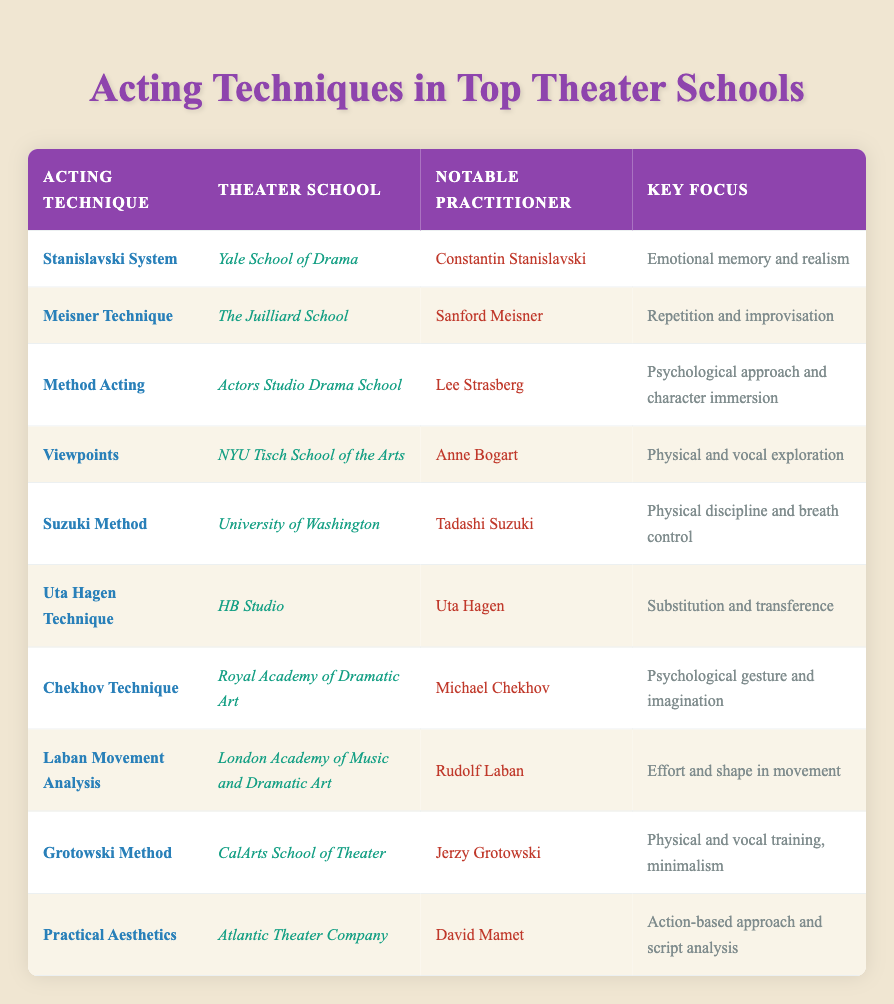What is the key focus of the Method Acting technique? The Method Acting technique is associated with the Actors Studio Drama School and emphasizes a psychological approach and character immersion. This information can be pulled directly from the row that corresponds to Method Acting.
Answer: Psychological approach and character immersion Which theater school teaches the Uta Hagen Technique? The Uta Hagen Technique is taught at HB Studio. This is found directly in the row for the Uta Hagen Technique.
Answer: HB Studio Is the Stanislavski System focused on physical discipline? The key focus of the Stanislavski System is emotional memory and realism, which indicates it is not focused on physical discipline. This can be verified by looking at the specific row for the Stanislavski System.
Answer: No What notable practitioner is associated with the Meisner Technique? The Meisner Technique is notably practiced by Sanford Meisner. This data point is evident in the corresponding row for the Meisner Technique.
Answer: Sanford Meisner Which technique has a focus on effort and shape in movement? The technique that focuses on effort and shape in movement is Laban Movement Analysis. This is identified by referring to the specific entry for that technique in the table.
Answer: Laban Movement Analysis How many different techniques have a psychological focus? The techniques with a psychological focus include Method Acting, Chekhov Technique, and Stanislavski System. That counts to three techniques. Each of these techniques emphasizes a psychological aspect, which can be confirmed by reviewing the key focuses in the table.
Answer: 3 Does the University of Washington teach the Suzuki Method? Yes, the Suzuki Method is taught at the University of Washington. This information is confirmed by looking at the respective row for the Suzuki Method.
Answer: Yes Which theater school has the most acting techniques associated with it? The Juilliard School has one technique (Meisner Technique) associated with it, while Yale School of Drama, HB Studio, and others also have one each. None of the schools have multiple techniques based on the table. Therefore, they are all equal in this regard.
Answer: None, all schools have one technique What is the commonality between the Viewpoints and Grotowski Method in terms of training approach? Both the Viewpoints and Grotowski Method emphasize physical training. The Viewpoints focus on physical and vocal exploration, while the Grotowski Method highlights physical and vocal training, indicating they share an emphasis on physicality.
Answer: Both emphasize physical training 